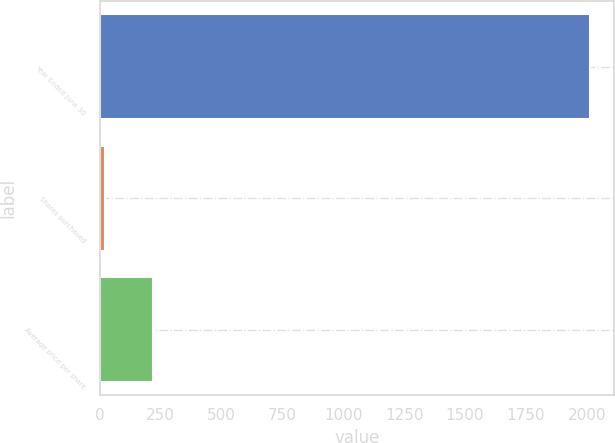<chart> <loc_0><loc_0><loc_500><loc_500><bar_chart><fcel>Year Ended June 30<fcel>Shares purchased<fcel>Average price per share<nl><fcel>2013<fcel>20<fcel>219.3<nl></chart> 